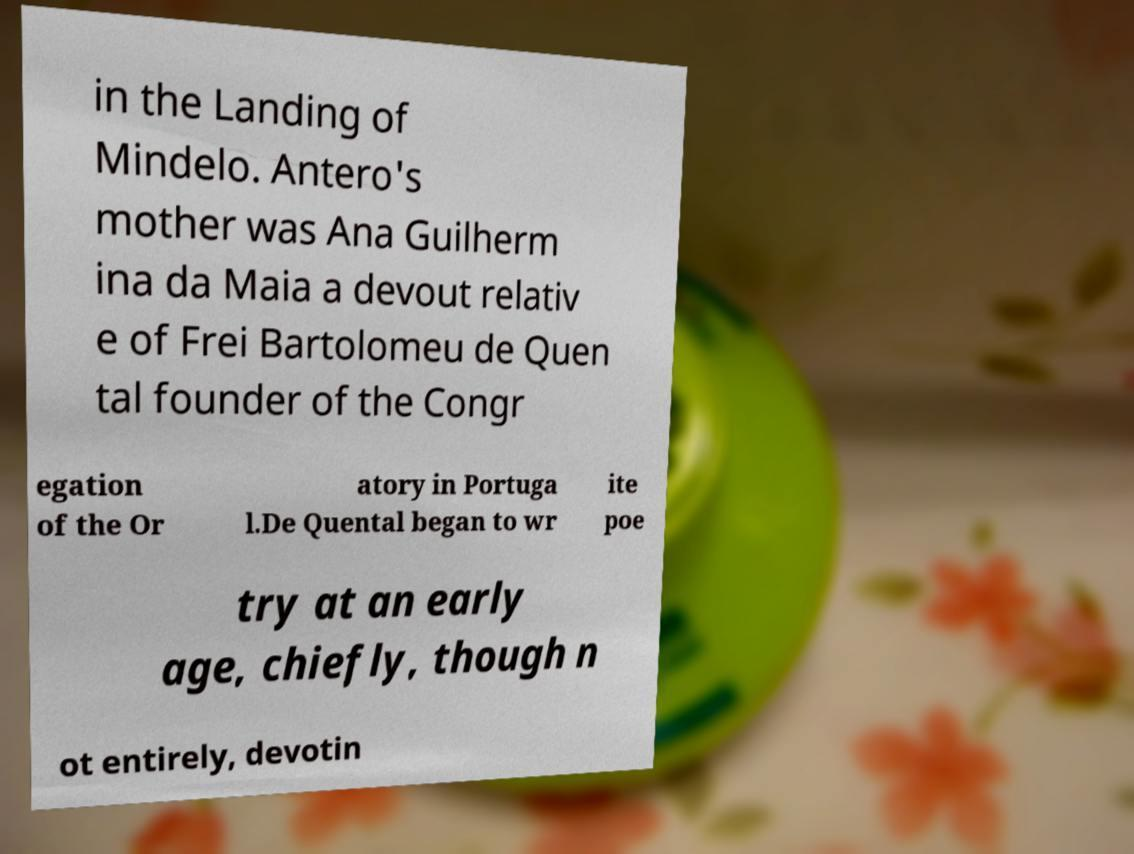Could you extract and type out the text from this image? in the Landing of Mindelo. Antero's mother was Ana Guilherm ina da Maia a devout relativ e of Frei Bartolomeu de Quen tal founder of the Congr egation of the Or atory in Portuga l.De Quental began to wr ite poe try at an early age, chiefly, though n ot entirely, devotin 